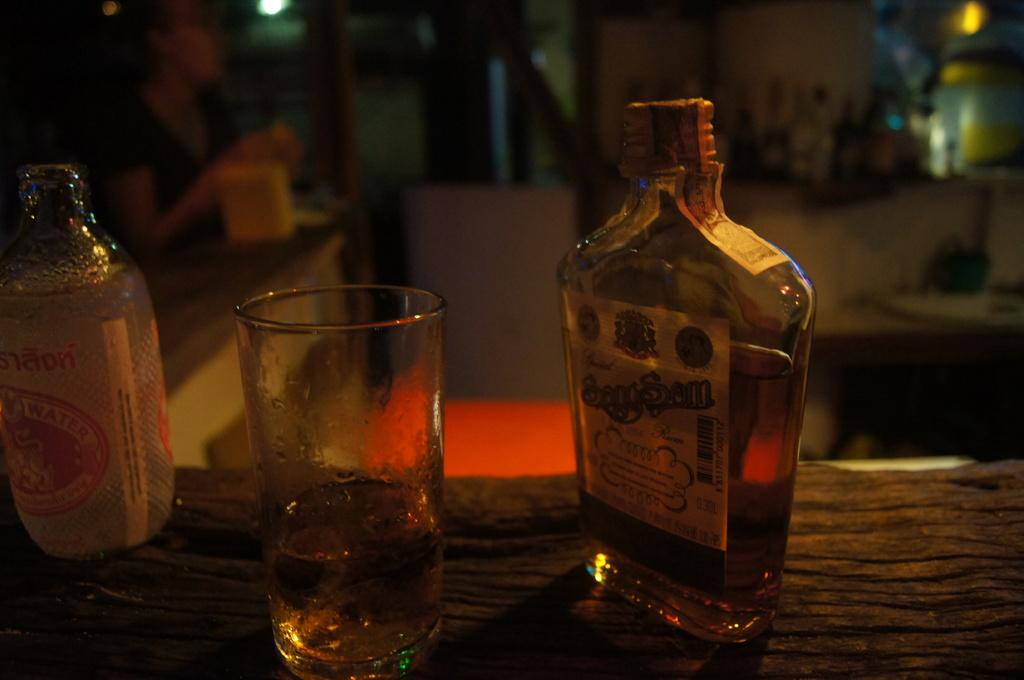<image>
Relay a brief, clear account of the picture shown. Bottle of Sagg Sam whiskey and glass on a table 